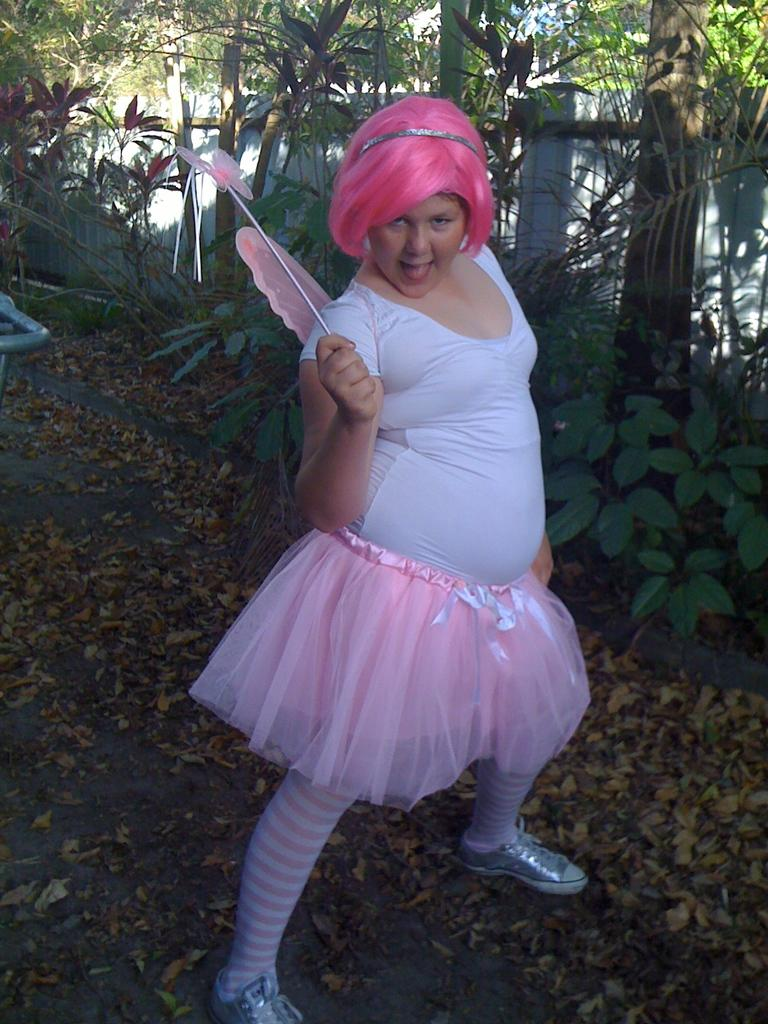What is present in the image? There is a person in the image. What can be seen in the background of the image? There are plants, trees, and a wall in the background of the image. What type of eye makeup is the person wearing in the image? There is no indication of eye makeup or any makeup in the image. Is there any sleet visible in the image? There is no sleet present in the image. What type of haircut does the person have in the image? There is no information about the person's haircut in the image. 